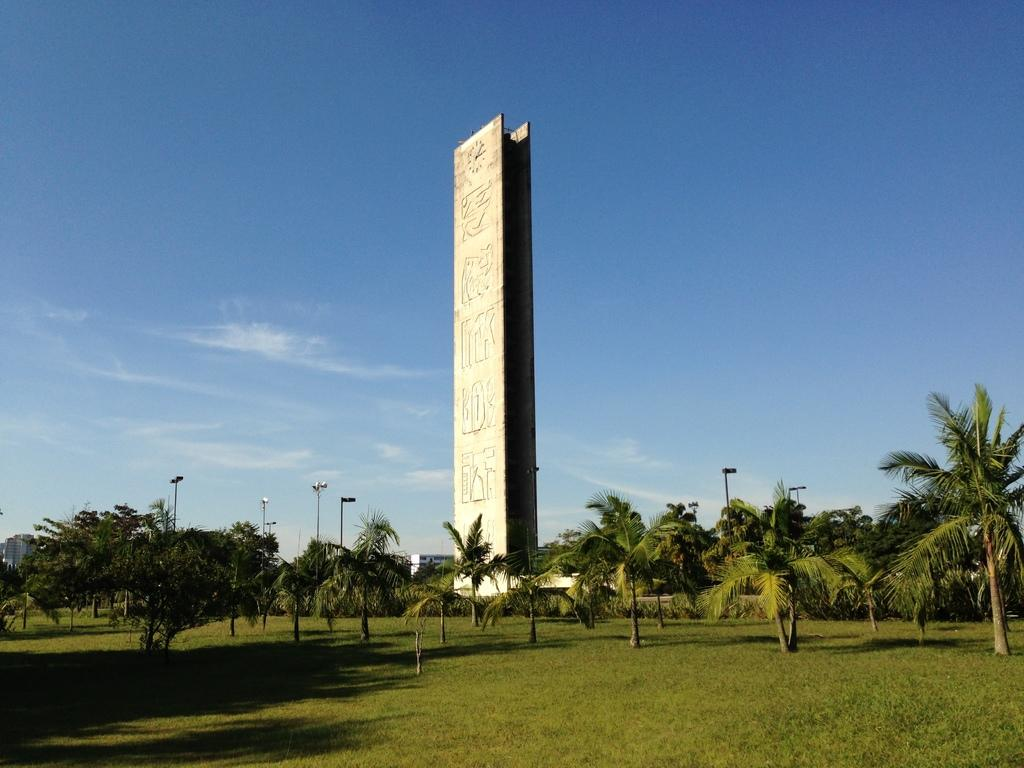Where was the image taken? The image was taken in a garden. What type of vegetation can be seen at the bottom of the image? There is green grass at the bottom of the image. What can be seen in the background of the image? There are trees and a big wall in the background of the image. What is visible at the top of the image? The sky is visible at the top of the image. How many dimes are scattered on the grass in the image? There are no dimes present in the image; it features a garden with green grass, trees, and a big wall. What type of bubble can be seen floating in the sky in the image? There is no bubble present in the image; it features a garden with green grass, trees, and a big wall, with the sky visible at the top. 